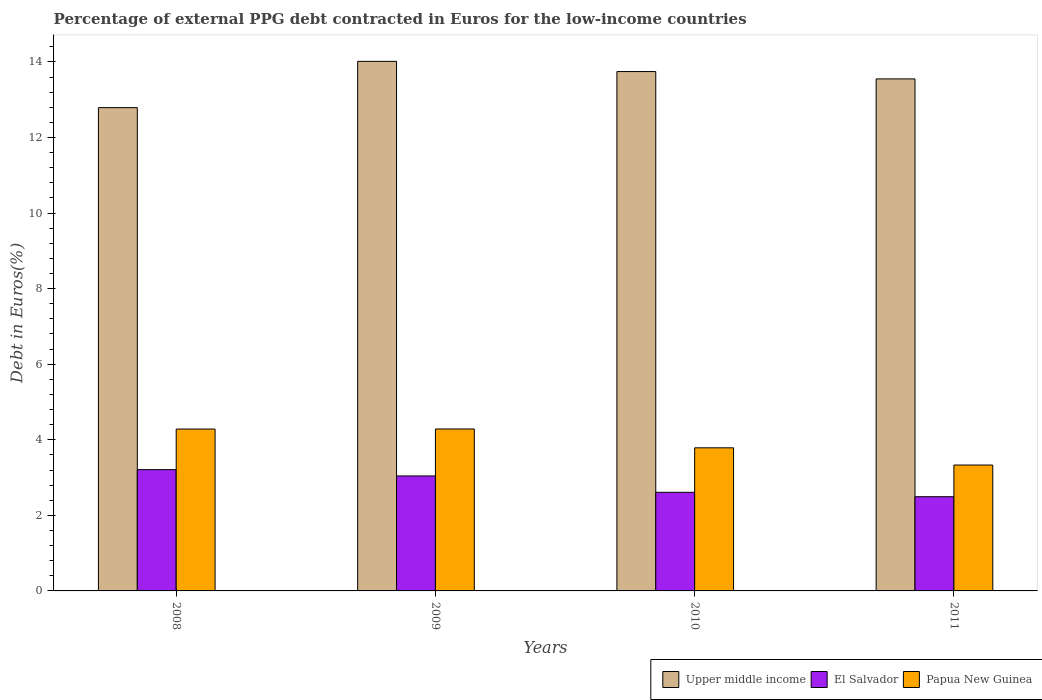How many groups of bars are there?
Provide a succinct answer. 4. In how many cases, is the number of bars for a given year not equal to the number of legend labels?
Your response must be concise. 0. What is the percentage of external PPG debt contracted in Euros in El Salvador in 2010?
Keep it short and to the point. 2.61. Across all years, what is the maximum percentage of external PPG debt contracted in Euros in Upper middle income?
Give a very brief answer. 14.02. Across all years, what is the minimum percentage of external PPG debt contracted in Euros in Papua New Guinea?
Give a very brief answer. 3.33. In which year was the percentage of external PPG debt contracted in Euros in Upper middle income minimum?
Keep it short and to the point. 2008. What is the total percentage of external PPG debt contracted in Euros in Upper middle income in the graph?
Keep it short and to the point. 54.1. What is the difference between the percentage of external PPG debt contracted in Euros in Papua New Guinea in 2009 and that in 2010?
Your answer should be compact. 0.5. What is the difference between the percentage of external PPG debt contracted in Euros in Papua New Guinea in 2011 and the percentage of external PPG debt contracted in Euros in El Salvador in 2009?
Your answer should be compact. 0.29. What is the average percentage of external PPG debt contracted in Euros in Papua New Guinea per year?
Keep it short and to the point. 3.92. In the year 2010, what is the difference between the percentage of external PPG debt contracted in Euros in Upper middle income and percentage of external PPG debt contracted in Euros in El Salvador?
Your response must be concise. 11.14. What is the ratio of the percentage of external PPG debt contracted in Euros in El Salvador in 2008 to that in 2010?
Offer a terse response. 1.23. Is the percentage of external PPG debt contracted in Euros in Upper middle income in 2009 less than that in 2011?
Offer a very short reply. No. What is the difference between the highest and the second highest percentage of external PPG debt contracted in Euros in Upper middle income?
Give a very brief answer. 0.27. What is the difference between the highest and the lowest percentage of external PPG debt contracted in Euros in El Salvador?
Your response must be concise. 0.72. In how many years, is the percentage of external PPG debt contracted in Euros in Upper middle income greater than the average percentage of external PPG debt contracted in Euros in Upper middle income taken over all years?
Make the answer very short. 3. Is the sum of the percentage of external PPG debt contracted in Euros in Upper middle income in 2009 and 2011 greater than the maximum percentage of external PPG debt contracted in Euros in El Salvador across all years?
Offer a very short reply. Yes. What does the 2nd bar from the left in 2008 represents?
Offer a very short reply. El Salvador. What does the 1st bar from the right in 2008 represents?
Your response must be concise. Papua New Guinea. How many bars are there?
Make the answer very short. 12. How many years are there in the graph?
Ensure brevity in your answer.  4. What is the difference between two consecutive major ticks on the Y-axis?
Your response must be concise. 2. Does the graph contain grids?
Provide a succinct answer. No. How are the legend labels stacked?
Offer a very short reply. Horizontal. What is the title of the graph?
Offer a terse response. Percentage of external PPG debt contracted in Euros for the low-income countries. Does "Qatar" appear as one of the legend labels in the graph?
Your answer should be compact. No. What is the label or title of the X-axis?
Offer a terse response. Years. What is the label or title of the Y-axis?
Keep it short and to the point. Debt in Euros(%). What is the Debt in Euros(%) in Upper middle income in 2008?
Your response must be concise. 12.79. What is the Debt in Euros(%) of El Salvador in 2008?
Give a very brief answer. 3.21. What is the Debt in Euros(%) in Papua New Guinea in 2008?
Offer a very short reply. 4.28. What is the Debt in Euros(%) of Upper middle income in 2009?
Offer a very short reply. 14.02. What is the Debt in Euros(%) of El Salvador in 2009?
Offer a terse response. 3.04. What is the Debt in Euros(%) in Papua New Guinea in 2009?
Your answer should be very brief. 4.29. What is the Debt in Euros(%) in Upper middle income in 2010?
Ensure brevity in your answer.  13.75. What is the Debt in Euros(%) of El Salvador in 2010?
Ensure brevity in your answer.  2.61. What is the Debt in Euros(%) of Papua New Guinea in 2010?
Your response must be concise. 3.79. What is the Debt in Euros(%) of Upper middle income in 2011?
Offer a terse response. 13.55. What is the Debt in Euros(%) of El Salvador in 2011?
Ensure brevity in your answer.  2.49. What is the Debt in Euros(%) in Papua New Guinea in 2011?
Your answer should be compact. 3.33. Across all years, what is the maximum Debt in Euros(%) in Upper middle income?
Keep it short and to the point. 14.02. Across all years, what is the maximum Debt in Euros(%) of El Salvador?
Keep it short and to the point. 3.21. Across all years, what is the maximum Debt in Euros(%) of Papua New Guinea?
Provide a short and direct response. 4.29. Across all years, what is the minimum Debt in Euros(%) in Upper middle income?
Keep it short and to the point. 12.79. Across all years, what is the minimum Debt in Euros(%) of El Salvador?
Ensure brevity in your answer.  2.49. Across all years, what is the minimum Debt in Euros(%) of Papua New Guinea?
Your response must be concise. 3.33. What is the total Debt in Euros(%) of Upper middle income in the graph?
Keep it short and to the point. 54.1. What is the total Debt in Euros(%) of El Salvador in the graph?
Keep it short and to the point. 11.36. What is the total Debt in Euros(%) of Papua New Guinea in the graph?
Give a very brief answer. 15.69. What is the difference between the Debt in Euros(%) of Upper middle income in 2008 and that in 2009?
Provide a succinct answer. -1.23. What is the difference between the Debt in Euros(%) of El Salvador in 2008 and that in 2009?
Your answer should be compact. 0.17. What is the difference between the Debt in Euros(%) in Papua New Guinea in 2008 and that in 2009?
Offer a terse response. -0. What is the difference between the Debt in Euros(%) of Upper middle income in 2008 and that in 2010?
Provide a short and direct response. -0.96. What is the difference between the Debt in Euros(%) of El Salvador in 2008 and that in 2010?
Your answer should be compact. 0.6. What is the difference between the Debt in Euros(%) of Papua New Guinea in 2008 and that in 2010?
Keep it short and to the point. 0.5. What is the difference between the Debt in Euros(%) of Upper middle income in 2008 and that in 2011?
Make the answer very short. -0.76. What is the difference between the Debt in Euros(%) of El Salvador in 2008 and that in 2011?
Offer a very short reply. 0.72. What is the difference between the Debt in Euros(%) of Papua New Guinea in 2008 and that in 2011?
Your response must be concise. 0.95. What is the difference between the Debt in Euros(%) in Upper middle income in 2009 and that in 2010?
Your answer should be very brief. 0.27. What is the difference between the Debt in Euros(%) in El Salvador in 2009 and that in 2010?
Offer a very short reply. 0.43. What is the difference between the Debt in Euros(%) in Papua New Guinea in 2009 and that in 2010?
Provide a succinct answer. 0.5. What is the difference between the Debt in Euros(%) in Upper middle income in 2009 and that in 2011?
Your answer should be very brief. 0.46. What is the difference between the Debt in Euros(%) in El Salvador in 2009 and that in 2011?
Make the answer very short. 0.55. What is the difference between the Debt in Euros(%) in Papua New Guinea in 2009 and that in 2011?
Offer a terse response. 0.95. What is the difference between the Debt in Euros(%) of Upper middle income in 2010 and that in 2011?
Make the answer very short. 0.19. What is the difference between the Debt in Euros(%) of El Salvador in 2010 and that in 2011?
Ensure brevity in your answer.  0.12. What is the difference between the Debt in Euros(%) of Papua New Guinea in 2010 and that in 2011?
Provide a short and direct response. 0.46. What is the difference between the Debt in Euros(%) of Upper middle income in 2008 and the Debt in Euros(%) of El Salvador in 2009?
Your answer should be compact. 9.75. What is the difference between the Debt in Euros(%) in Upper middle income in 2008 and the Debt in Euros(%) in Papua New Guinea in 2009?
Your answer should be compact. 8.5. What is the difference between the Debt in Euros(%) in El Salvador in 2008 and the Debt in Euros(%) in Papua New Guinea in 2009?
Your answer should be compact. -1.08. What is the difference between the Debt in Euros(%) in Upper middle income in 2008 and the Debt in Euros(%) in El Salvador in 2010?
Make the answer very short. 10.18. What is the difference between the Debt in Euros(%) in Upper middle income in 2008 and the Debt in Euros(%) in Papua New Guinea in 2010?
Your response must be concise. 9. What is the difference between the Debt in Euros(%) in El Salvador in 2008 and the Debt in Euros(%) in Papua New Guinea in 2010?
Provide a short and direct response. -0.58. What is the difference between the Debt in Euros(%) of Upper middle income in 2008 and the Debt in Euros(%) of El Salvador in 2011?
Provide a succinct answer. 10.3. What is the difference between the Debt in Euros(%) of Upper middle income in 2008 and the Debt in Euros(%) of Papua New Guinea in 2011?
Provide a short and direct response. 9.46. What is the difference between the Debt in Euros(%) in El Salvador in 2008 and the Debt in Euros(%) in Papua New Guinea in 2011?
Your answer should be very brief. -0.12. What is the difference between the Debt in Euros(%) in Upper middle income in 2009 and the Debt in Euros(%) in El Salvador in 2010?
Your answer should be very brief. 11.41. What is the difference between the Debt in Euros(%) in Upper middle income in 2009 and the Debt in Euros(%) in Papua New Guinea in 2010?
Make the answer very short. 10.23. What is the difference between the Debt in Euros(%) of El Salvador in 2009 and the Debt in Euros(%) of Papua New Guinea in 2010?
Offer a very short reply. -0.74. What is the difference between the Debt in Euros(%) in Upper middle income in 2009 and the Debt in Euros(%) in El Salvador in 2011?
Your response must be concise. 11.52. What is the difference between the Debt in Euros(%) in Upper middle income in 2009 and the Debt in Euros(%) in Papua New Guinea in 2011?
Your answer should be very brief. 10.68. What is the difference between the Debt in Euros(%) of El Salvador in 2009 and the Debt in Euros(%) of Papua New Guinea in 2011?
Offer a very short reply. -0.29. What is the difference between the Debt in Euros(%) of Upper middle income in 2010 and the Debt in Euros(%) of El Salvador in 2011?
Offer a very short reply. 11.25. What is the difference between the Debt in Euros(%) of Upper middle income in 2010 and the Debt in Euros(%) of Papua New Guinea in 2011?
Ensure brevity in your answer.  10.41. What is the difference between the Debt in Euros(%) of El Salvador in 2010 and the Debt in Euros(%) of Papua New Guinea in 2011?
Make the answer very short. -0.72. What is the average Debt in Euros(%) in Upper middle income per year?
Your answer should be compact. 13.53. What is the average Debt in Euros(%) in El Salvador per year?
Keep it short and to the point. 2.84. What is the average Debt in Euros(%) of Papua New Guinea per year?
Your response must be concise. 3.92. In the year 2008, what is the difference between the Debt in Euros(%) of Upper middle income and Debt in Euros(%) of El Salvador?
Give a very brief answer. 9.58. In the year 2008, what is the difference between the Debt in Euros(%) in Upper middle income and Debt in Euros(%) in Papua New Guinea?
Provide a short and direct response. 8.51. In the year 2008, what is the difference between the Debt in Euros(%) in El Salvador and Debt in Euros(%) in Papua New Guinea?
Provide a short and direct response. -1.07. In the year 2009, what is the difference between the Debt in Euros(%) of Upper middle income and Debt in Euros(%) of El Salvador?
Your answer should be very brief. 10.97. In the year 2009, what is the difference between the Debt in Euros(%) of Upper middle income and Debt in Euros(%) of Papua New Guinea?
Provide a short and direct response. 9.73. In the year 2009, what is the difference between the Debt in Euros(%) in El Salvador and Debt in Euros(%) in Papua New Guinea?
Offer a terse response. -1.24. In the year 2010, what is the difference between the Debt in Euros(%) of Upper middle income and Debt in Euros(%) of El Salvador?
Ensure brevity in your answer.  11.14. In the year 2010, what is the difference between the Debt in Euros(%) in Upper middle income and Debt in Euros(%) in Papua New Guinea?
Offer a terse response. 9.96. In the year 2010, what is the difference between the Debt in Euros(%) in El Salvador and Debt in Euros(%) in Papua New Guinea?
Your response must be concise. -1.18. In the year 2011, what is the difference between the Debt in Euros(%) in Upper middle income and Debt in Euros(%) in El Salvador?
Your answer should be compact. 11.06. In the year 2011, what is the difference between the Debt in Euros(%) in Upper middle income and Debt in Euros(%) in Papua New Guinea?
Provide a succinct answer. 10.22. In the year 2011, what is the difference between the Debt in Euros(%) in El Salvador and Debt in Euros(%) in Papua New Guinea?
Offer a very short reply. -0.84. What is the ratio of the Debt in Euros(%) in Upper middle income in 2008 to that in 2009?
Offer a terse response. 0.91. What is the ratio of the Debt in Euros(%) of El Salvador in 2008 to that in 2009?
Make the answer very short. 1.05. What is the ratio of the Debt in Euros(%) of Papua New Guinea in 2008 to that in 2009?
Keep it short and to the point. 1. What is the ratio of the Debt in Euros(%) in Upper middle income in 2008 to that in 2010?
Provide a succinct answer. 0.93. What is the ratio of the Debt in Euros(%) of El Salvador in 2008 to that in 2010?
Keep it short and to the point. 1.23. What is the ratio of the Debt in Euros(%) of Papua New Guinea in 2008 to that in 2010?
Your answer should be compact. 1.13. What is the ratio of the Debt in Euros(%) of Upper middle income in 2008 to that in 2011?
Give a very brief answer. 0.94. What is the ratio of the Debt in Euros(%) of El Salvador in 2008 to that in 2011?
Provide a succinct answer. 1.29. What is the ratio of the Debt in Euros(%) in Papua New Guinea in 2008 to that in 2011?
Offer a very short reply. 1.29. What is the ratio of the Debt in Euros(%) in Upper middle income in 2009 to that in 2010?
Provide a succinct answer. 1.02. What is the ratio of the Debt in Euros(%) in El Salvador in 2009 to that in 2010?
Offer a very short reply. 1.17. What is the ratio of the Debt in Euros(%) in Papua New Guinea in 2009 to that in 2010?
Keep it short and to the point. 1.13. What is the ratio of the Debt in Euros(%) in Upper middle income in 2009 to that in 2011?
Offer a terse response. 1.03. What is the ratio of the Debt in Euros(%) in El Salvador in 2009 to that in 2011?
Offer a very short reply. 1.22. What is the ratio of the Debt in Euros(%) in Papua New Guinea in 2009 to that in 2011?
Offer a very short reply. 1.29. What is the ratio of the Debt in Euros(%) of Upper middle income in 2010 to that in 2011?
Keep it short and to the point. 1.01. What is the ratio of the Debt in Euros(%) in El Salvador in 2010 to that in 2011?
Ensure brevity in your answer.  1.05. What is the ratio of the Debt in Euros(%) of Papua New Guinea in 2010 to that in 2011?
Provide a succinct answer. 1.14. What is the difference between the highest and the second highest Debt in Euros(%) in Upper middle income?
Provide a short and direct response. 0.27. What is the difference between the highest and the second highest Debt in Euros(%) in El Salvador?
Offer a very short reply. 0.17. What is the difference between the highest and the second highest Debt in Euros(%) in Papua New Guinea?
Your answer should be very brief. 0. What is the difference between the highest and the lowest Debt in Euros(%) in Upper middle income?
Offer a very short reply. 1.23. What is the difference between the highest and the lowest Debt in Euros(%) in El Salvador?
Offer a terse response. 0.72. What is the difference between the highest and the lowest Debt in Euros(%) of Papua New Guinea?
Make the answer very short. 0.95. 